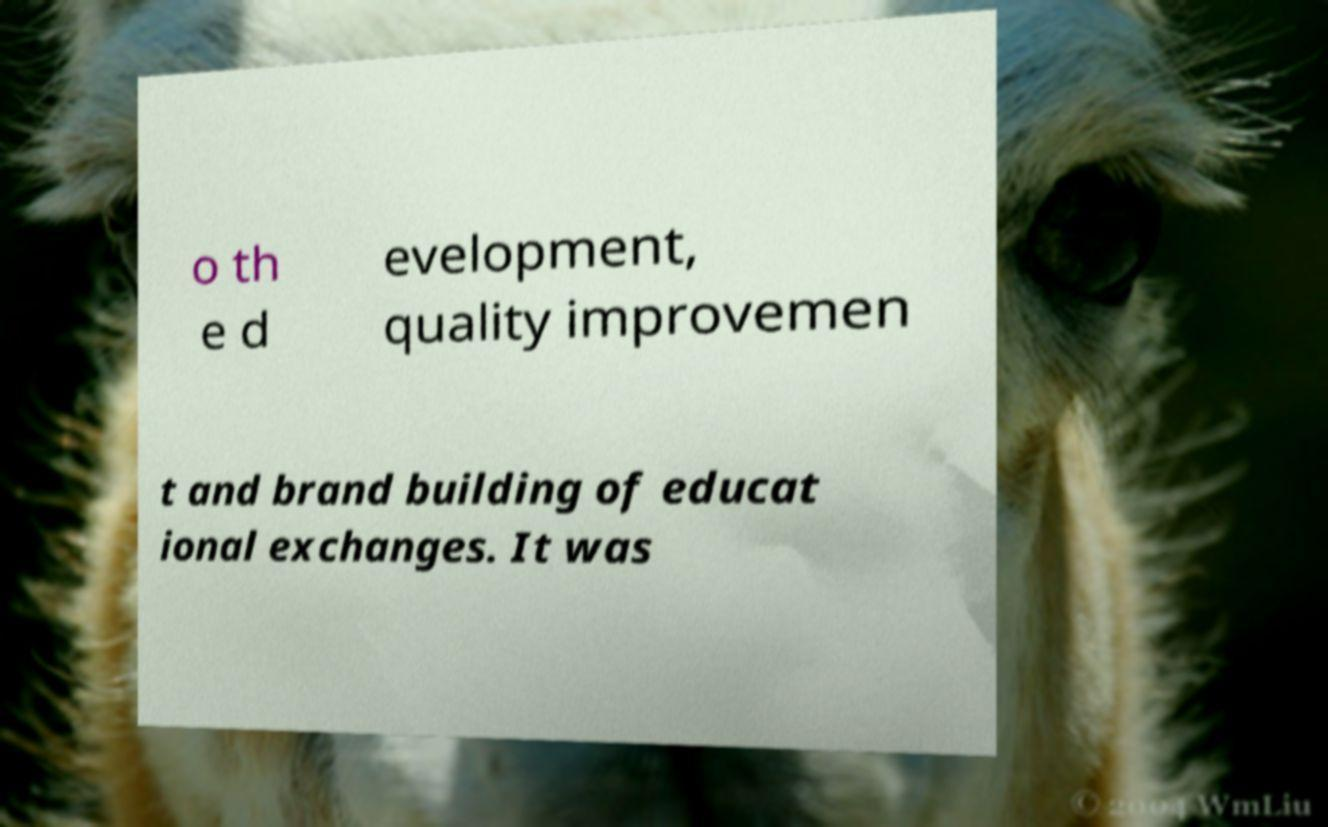I need the written content from this picture converted into text. Can you do that? o th e d evelopment, quality improvemen t and brand building of educat ional exchanges. It was 